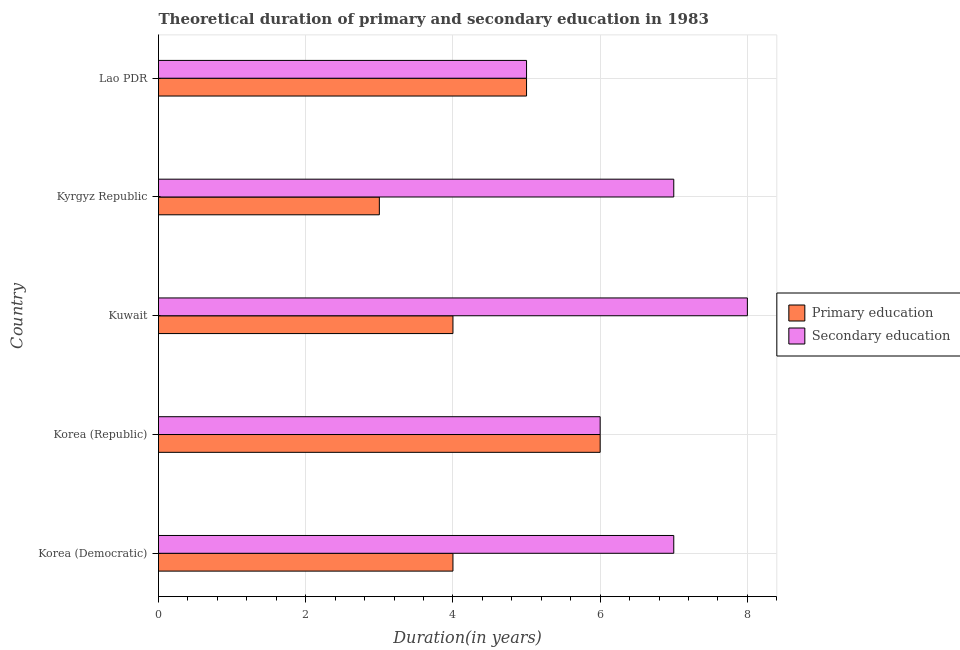How many different coloured bars are there?
Ensure brevity in your answer.  2. Are the number of bars per tick equal to the number of legend labels?
Provide a short and direct response. Yes. How many bars are there on the 2nd tick from the top?
Give a very brief answer. 2. What is the label of the 5th group of bars from the top?
Offer a very short reply. Korea (Democratic). What is the duration of primary education in Lao PDR?
Your answer should be very brief. 5. Across all countries, what is the maximum duration of secondary education?
Your answer should be very brief. 8. Across all countries, what is the minimum duration of primary education?
Provide a short and direct response. 3. In which country was the duration of secondary education minimum?
Ensure brevity in your answer.  Lao PDR. What is the total duration of primary education in the graph?
Your response must be concise. 22. What is the difference between the duration of secondary education in Korea (Democratic) and that in Korea (Republic)?
Your response must be concise. 1. What is the difference between the duration of secondary education in Kuwait and the duration of primary education in Korea (Republic)?
Provide a short and direct response. 2. What is the average duration of secondary education per country?
Keep it short and to the point. 6.6. What is the difference between the duration of secondary education and duration of primary education in Kuwait?
Keep it short and to the point. 4. Is the duration of secondary education in Korea (Republic) less than that in Kuwait?
Offer a very short reply. Yes. What is the difference between the highest and the lowest duration of secondary education?
Keep it short and to the point. 3. What does the 1st bar from the top in Lao PDR represents?
Your answer should be compact. Secondary education. What does the 1st bar from the bottom in Lao PDR represents?
Keep it short and to the point. Primary education. Are all the bars in the graph horizontal?
Give a very brief answer. Yes. Are the values on the major ticks of X-axis written in scientific E-notation?
Offer a terse response. No. Does the graph contain any zero values?
Provide a short and direct response. No. What is the title of the graph?
Make the answer very short. Theoretical duration of primary and secondary education in 1983. What is the label or title of the X-axis?
Offer a terse response. Duration(in years). What is the label or title of the Y-axis?
Provide a short and direct response. Country. What is the Duration(in years) in Secondary education in Korea (Republic)?
Offer a very short reply. 6. What is the Duration(in years) of Secondary education in Kuwait?
Provide a short and direct response. 8. What is the Duration(in years) in Primary education in Kyrgyz Republic?
Make the answer very short. 3. What is the Duration(in years) of Secondary education in Kyrgyz Republic?
Offer a very short reply. 7. What is the Duration(in years) in Primary education in Lao PDR?
Offer a terse response. 5. What is the Duration(in years) of Secondary education in Lao PDR?
Your response must be concise. 5. Across all countries, what is the maximum Duration(in years) of Primary education?
Offer a very short reply. 6. Across all countries, what is the minimum Duration(in years) of Primary education?
Offer a very short reply. 3. Across all countries, what is the minimum Duration(in years) in Secondary education?
Your response must be concise. 5. What is the total Duration(in years) of Secondary education in the graph?
Provide a succinct answer. 33. What is the difference between the Duration(in years) in Secondary education in Korea (Democratic) and that in Korea (Republic)?
Offer a terse response. 1. What is the difference between the Duration(in years) in Primary education in Korea (Democratic) and that in Kuwait?
Give a very brief answer. 0. What is the difference between the Duration(in years) of Secondary education in Korea (Democratic) and that in Kuwait?
Your response must be concise. -1. What is the difference between the Duration(in years) of Primary education in Korea (Democratic) and that in Kyrgyz Republic?
Provide a short and direct response. 1. What is the difference between the Duration(in years) in Secondary education in Korea (Democratic) and that in Lao PDR?
Your answer should be very brief. 2. What is the difference between the Duration(in years) in Primary education in Korea (Republic) and that in Kuwait?
Make the answer very short. 2. What is the difference between the Duration(in years) of Secondary education in Korea (Republic) and that in Kuwait?
Your answer should be very brief. -2. What is the difference between the Duration(in years) of Secondary education in Korea (Republic) and that in Kyrgyz Republic?
Provide a succinct answer. -1. What is the difference between the Duration(in years) of Primary education in Korea (Republic) and that in Lao PDR?
Offer a terse response. 1. What is the difference between the Duration(in years) in Secondary education in Korea (Republic) and that in Lao PDR?
Provide a succinct answer. 1. What is the difference between the Duration(in years) in Primary education in Kuwait and that in Lao PDR?
Give a very brief answer. -1. What is the difference between the Duration(in years) in Secondary education in Kuwait and that in Lao PDR?
Make the answer very short. 3. What is the difference between the Duration(in years) in Secondary education in Kyrgyz Republic and that in Lao PDR?
Provide a short and direct response. 2. What is the difference between the Duration(in years) of Primary education in Korea (Democratic) and the Duration(in years) of Secondary education in Kuwait?
Your answer should be compact. -4. What is the difference between the Duration(in years) in Primary education in Korea (Republic) and the Duration(in years) in Secondary education in Kuwait?
Provide a short and direct response. -2. What is the difference between the Duration(in years) in Primary education in Korea (Republic) and the Duration(in years) in Secondary education in Kyrgyz Republic?
Provide a succinct answer. -1. What is the difference between the Duration(in years) in Primary education in Kuwait and the Duration(in years) in Secondary education in Lao PDR?
Offer a very short reply. -1. What is the difference between the Duration(in years) in Primary education in Kyrgyz Republic and the Duration(in years) in Secondary education in Lao PDR?
Keep it short and to the point. -2. What is the average Duration(in years) in Secondary education per country?
Keep it short and to the point. 6.6. What is the difference between the Duration(in years) of Primary education and Duration(in years) of Secondary education in Korea (Republic)?
Keep it short and to the point. 0. What is the difference between the Duration(in years) in Primary education and Duration(in years) in Secondary education in Kuwait?
Ensure brevity in your answer.  -4. What is the ratio of the Duration(in years) in Secondary education in Korea (Democratic) to that in Korea (Republic)?
Your response must be concise. 1.17. What is the ratio of the Duration(in years) in Primary education in Korea (Democratic) to that in Kuwait?
Your response must be concise. 1. What is the ratio of the Duration(in years) in Primary education in Korea (Democratic) to that in Kyrgyz Republic?
Keep it short and to the point. 1.33. What is the ratio of the Duration(in years) in Secondary education in Korea (Democratic) to that in Kyrgyz Republic?
Your response must be concise. 1. What is the ratio of the Duration(in years) of Primary education in Korea (Democratic) to that in Lao PDR?
Make the answer very short. 0.8. What is the ratio of the Duration(in years) in Secondary education in Korea (Democratic) to that in Lao PDR?
Your answer should be very brief. 1.4. What is the ratio of the Duration(in years) of Secondary education in Korea (Republic) to that in Lao PDR?
Make the answer very short. 1.2. What is the ratio of the Duration(in years) in Secondary education in Kuwait to that in Kyrgyz Republic?
Offer a very short reply. 1.14. What is the ratio of the Duration(in years) of Secondary education in Kuwait to that in Lao PDR?
Offer a very short reply. 1.6. What is the difference between the highest and the second highest Duration(in years) of Secondary education?
Provide a succinct answer. 1. 